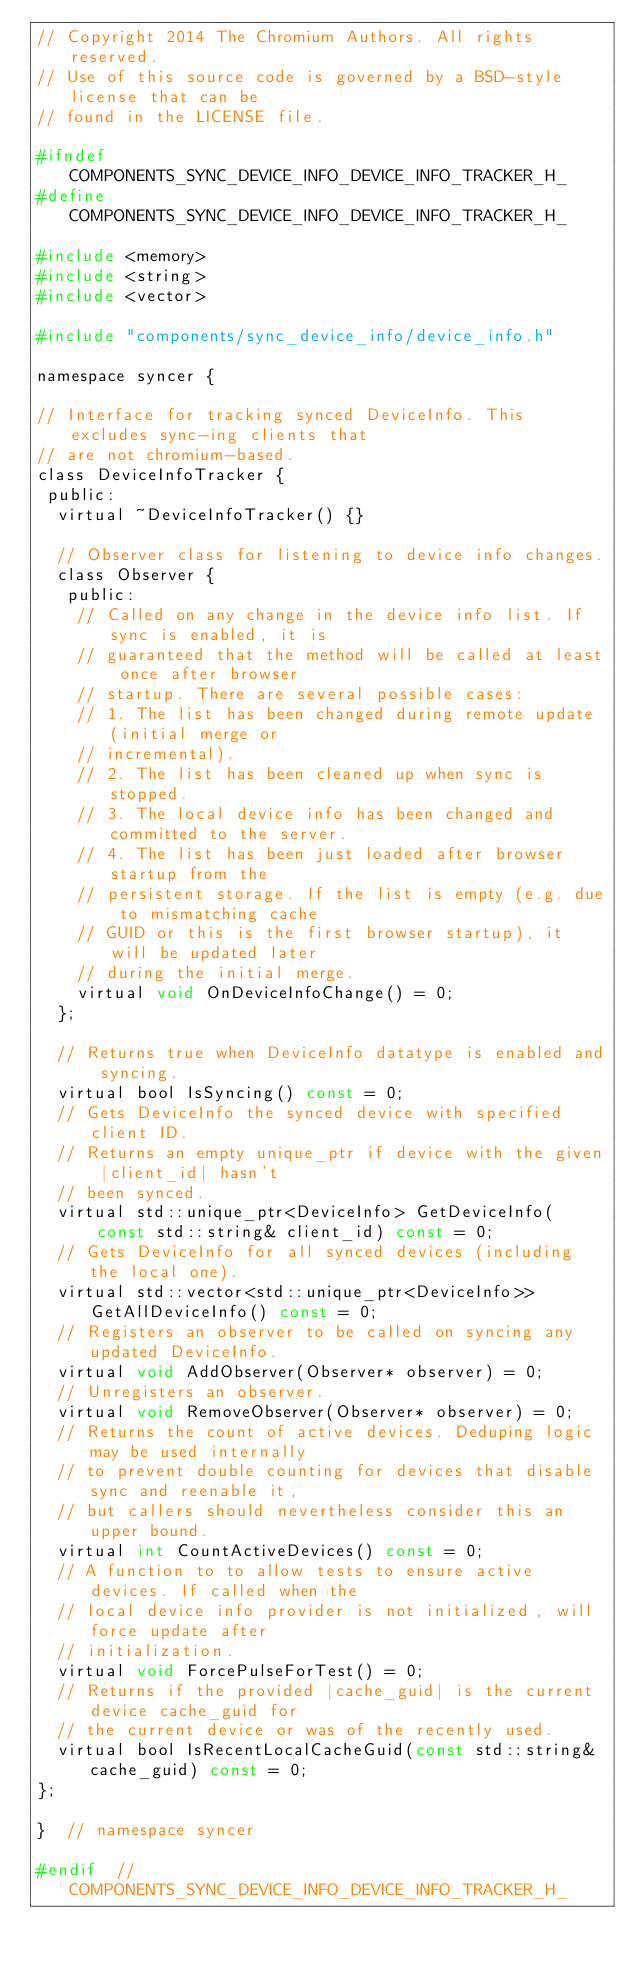<code> <loc_0><loc_0><loc_500><loc_500><_C_>// Copyright 2014 The Chromium Authors. All rights reserved.
// Use of this source code is governed by a BSD-style license that can be
// found in the LICENSE file.

#ifndef COMPONENTS_SYNC_DEVICE_INFO_DEVICE_INFO_TRACKER_H_
#define COMPONENTS_SYNC_DEVICE_INFO_DEVICE_INFO_TRACKER_H_

#include <memory>
#include <string>
#include <vector>

#include "components/sync_device_info/device_info.h"

namespace syncer {

// Interface for tracking synced DeviceInfo. This excludes sync-ing clients that
// are not chromium-based.
class DeviceInfoTracker {
 public:
  virtual ~DeviceInfoTracker() {}

  // Observer class for listening to device info changes.
  class Observer {
   public:
    // Called on any change in the device info list. If sync is enabled, it is
    // guaranteed that the method will be called at least once after browser
    // startup. There are several possible cases:
    // 1. The list has been changed during remote update (initial merge or
    // incremental).
    // 2. The list has been cleaned up when sync is stopped.
    // 3. The local device info has been changed and committed to the server.
    // 4. The list has been just loaded after browser startup from the
    // persistent storage. If the list is empty (e.g. due to mismatching cache
    // GUID or this is the first browser startup), it will be updated later
    // during the initial merge.
    virtual void OnDeviceInfoChange() = 0;
  };

  // Returns true when DeviceInfo datatype is enabled and syncing.
  virtual bool IsSyncing() const = 0;
  // Gets DeviceInfo the synced device with specified client ID.
  // Returns an empty unique_ptr if device with the given |client_id| hasn't
  // been synced.
  virtual std::unique_ptr<DeviceInfo> GetDeviceInfo(
      const std::string& client_id) const = 0;
  // Gets DeviceInfo for all synced devices (including the local one).
  virtual std::vector<std::unique_ptr<DeviceInfo>> GetAllDeviceInfo() const = 0;
  // Registers an observer to be called on syncing any updated DeviceInfo.
  virtual void AddObserver(Observer* observer) = 0;
  // Unregisters an observer.
  virtual void RemoveObserver(Observer* observer) = 0;
  // Returns the count of active devices. Deduping logic may be used internally
  // to prevent double counting for devices that disable sync and reenable it,
  // but callers should nevertheless consider this an upper bound.
  virtual int CountActiveDevices() const = 0;
  // A function to to allow tests to ensure active devices. If called when the
  // local device info provider is not initialized, will force update after
  // initialization.
  virtual void ForcePulseForTest() = 0;
  // Returns if the provided |cache_guid| is the current device cache_guid for
  // the current device or was of the recently used.
  virtual bool IsRecentLocalCacheGuid(const std::string& cache_guid) const = 0;
};

}  // namespace syncer

#endif  // COMPONENTS_SYNC_DEVICE_INFO_DEVICE_INFO_TRACKER_H_
</code> 